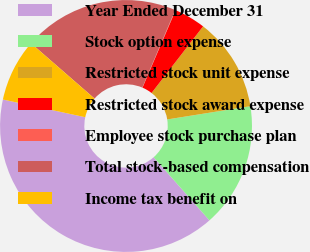Convert chart to OTSL. <chart><loc_0><loc_0><loc_500><loc_500><pie_chart><fcel>Year Ended December 31<fcel>Stock option expense<fcel>Restricted stock unit expense<fcel>Restricted stock award expense<fcel>Employee stock purchase plan<fcel>Total stock-based compensation<fcel>Income tax benefit on<nl><fcel>39.89%<fcel>15.99%<fcel>12.01%<fcel>4.04%<fcel>0.06%<fcel>19.98%<fcel>8.03%<nl></chart> 